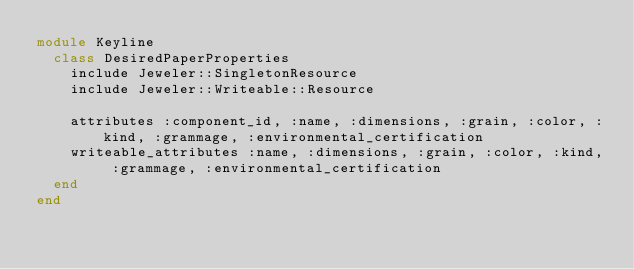Convert code to text. <code><loc_0><loc_0><loc_500><loc_500><_Ruby_>module Keyline
  class DesiredPaperProperties
    include Jeweler::SingletonResource
    include Jeweler::Writeable::Resource

    attributes :component_id, :name, :dimensions, :grain, :color, :kind, :grammage, :environmental_certification
    writeable_attributes :name, :dimensions, :grain, :color, :kind, :grammage, :environmental_certification
  end
end
</code> 